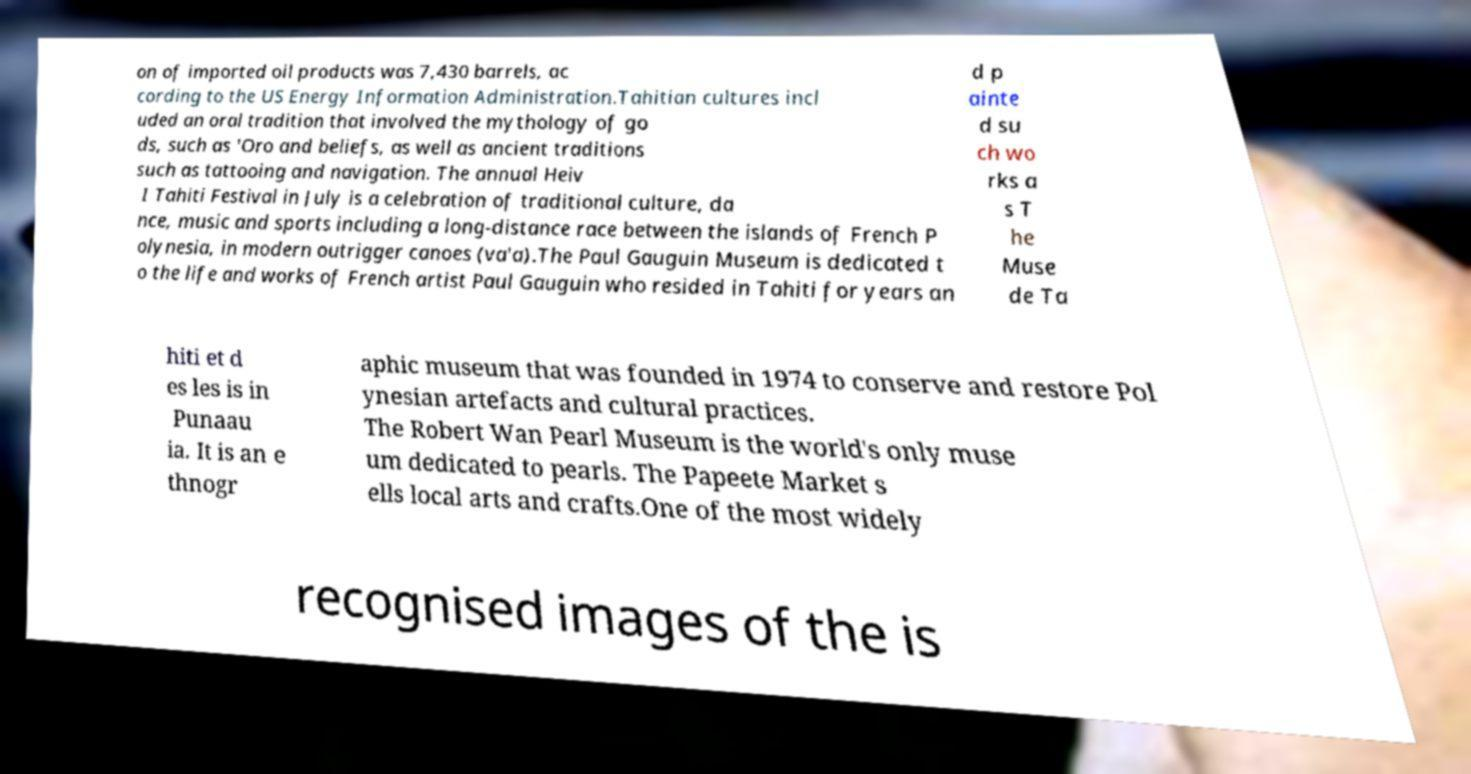Please identify and transcribe the text found in this image. on of imported oil products was 7,430 barrels, ac cording to the US Energy Information Administration.Tahitian cultures incl uded an oral tradition that involved the mythology of go ds, such as 'Oro and beliefs, as well as ancient traditions such as tattooing and navigation. The annual Heiv I Tahiti Festival in July is a celebration of traditional culture, da nce, music and sports including a long-distance race between the islands of French P olynesia, in modern outrigger canoes (va'a).The Paul Gauguin Museum is dedicated t o the life and works of French artist Paul Gauguin who resided in Tahiti for years an d p ainte d su ch wo rks a s T he Muse de Ta hiti et d es les is in Punaau ia. It is an e thnogr aphic museum that was founded in 1974 to conserve and restore Pol ynesian artefacts and cultural practices. The Robert Wan Pearl Museum is the world's only muse um dedicated to pearls. The Papeete Market s ells local arts and crafts.One of the most widely recognised images of the is 